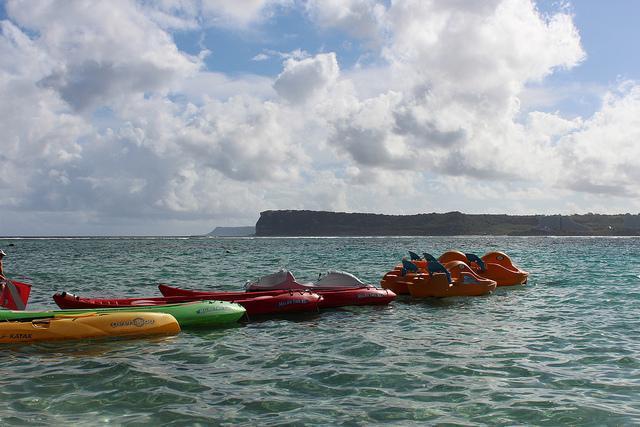How many boats are there?
Give a very brief answer. 6. How many people are wearing orange shirts?
Give a very brief answer. 0. 